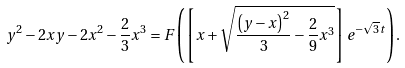<formula> <loc_0><loc_0><loc_500><loc_500>y ^ { 2 } - 2 x y - 2 x ^ { 2 } - \frac { 2 } { 3 } x ^ { 3 } = F \left ( \left [ x + \sqrt { \frac { \left ( y - x \right ) ^ { 2 } } { 3 } - \frac { 2 } { 9 } x ^ { 3 } } \right ] e ^ { - { \sqrt { 3 } } t } \right ) .</formula> 